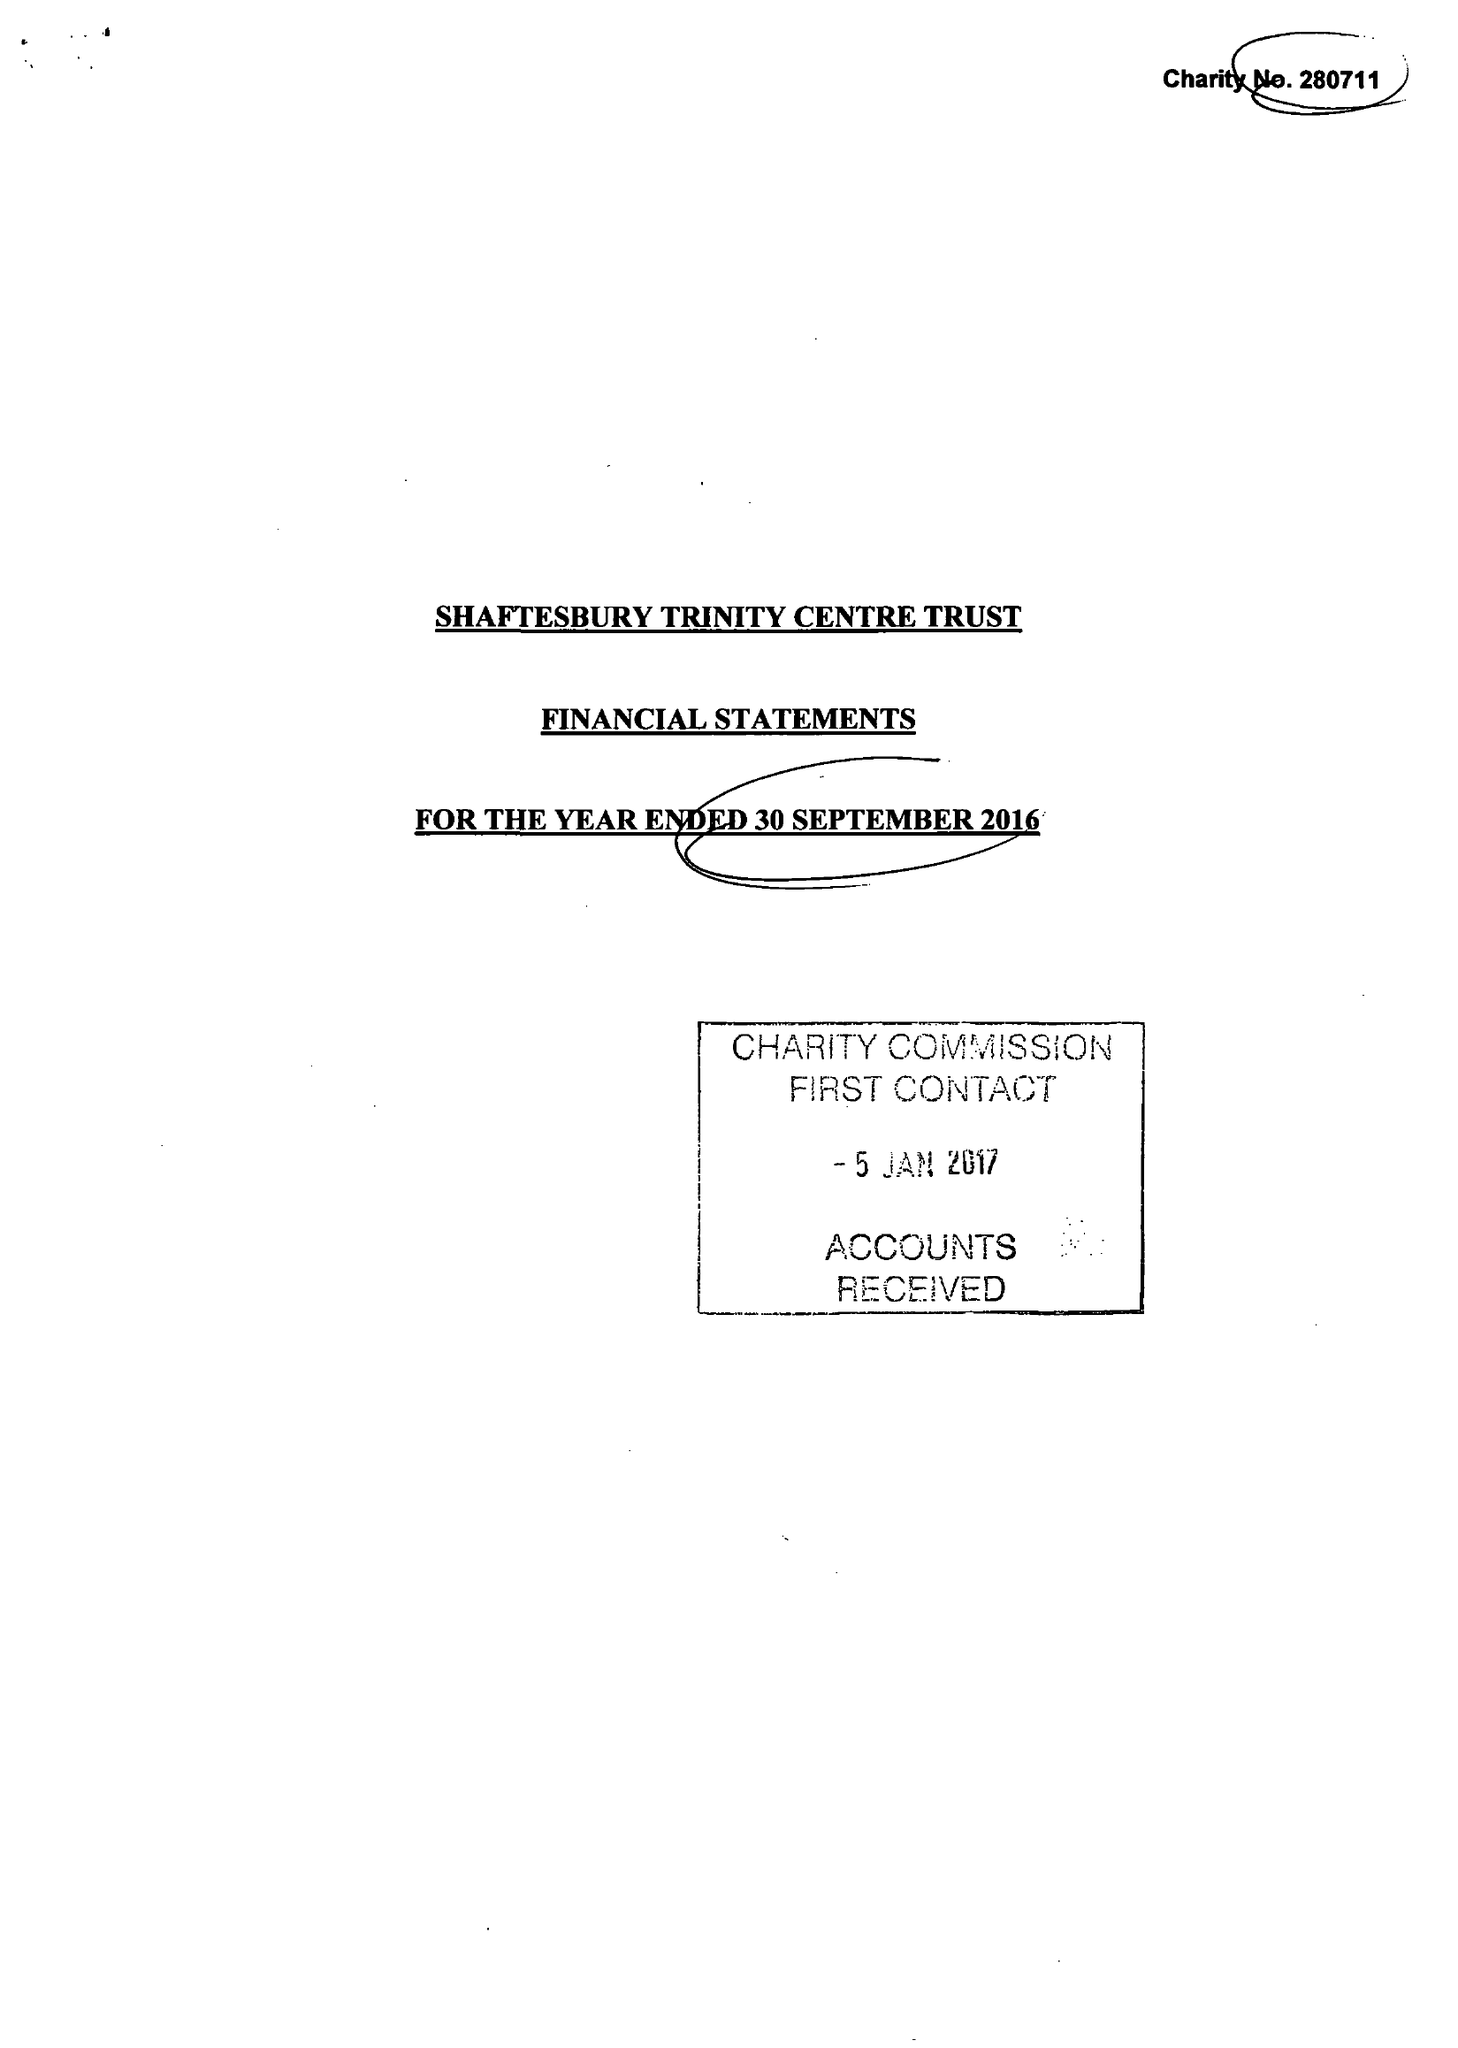What is the value for the spending_annually_in_british_pounds?
Answer the question using a single word or phrase. 86039.00 